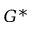<formula> <loc_0><loc_0><loc_500><loc_500>G ^ { \ast }</formula> 